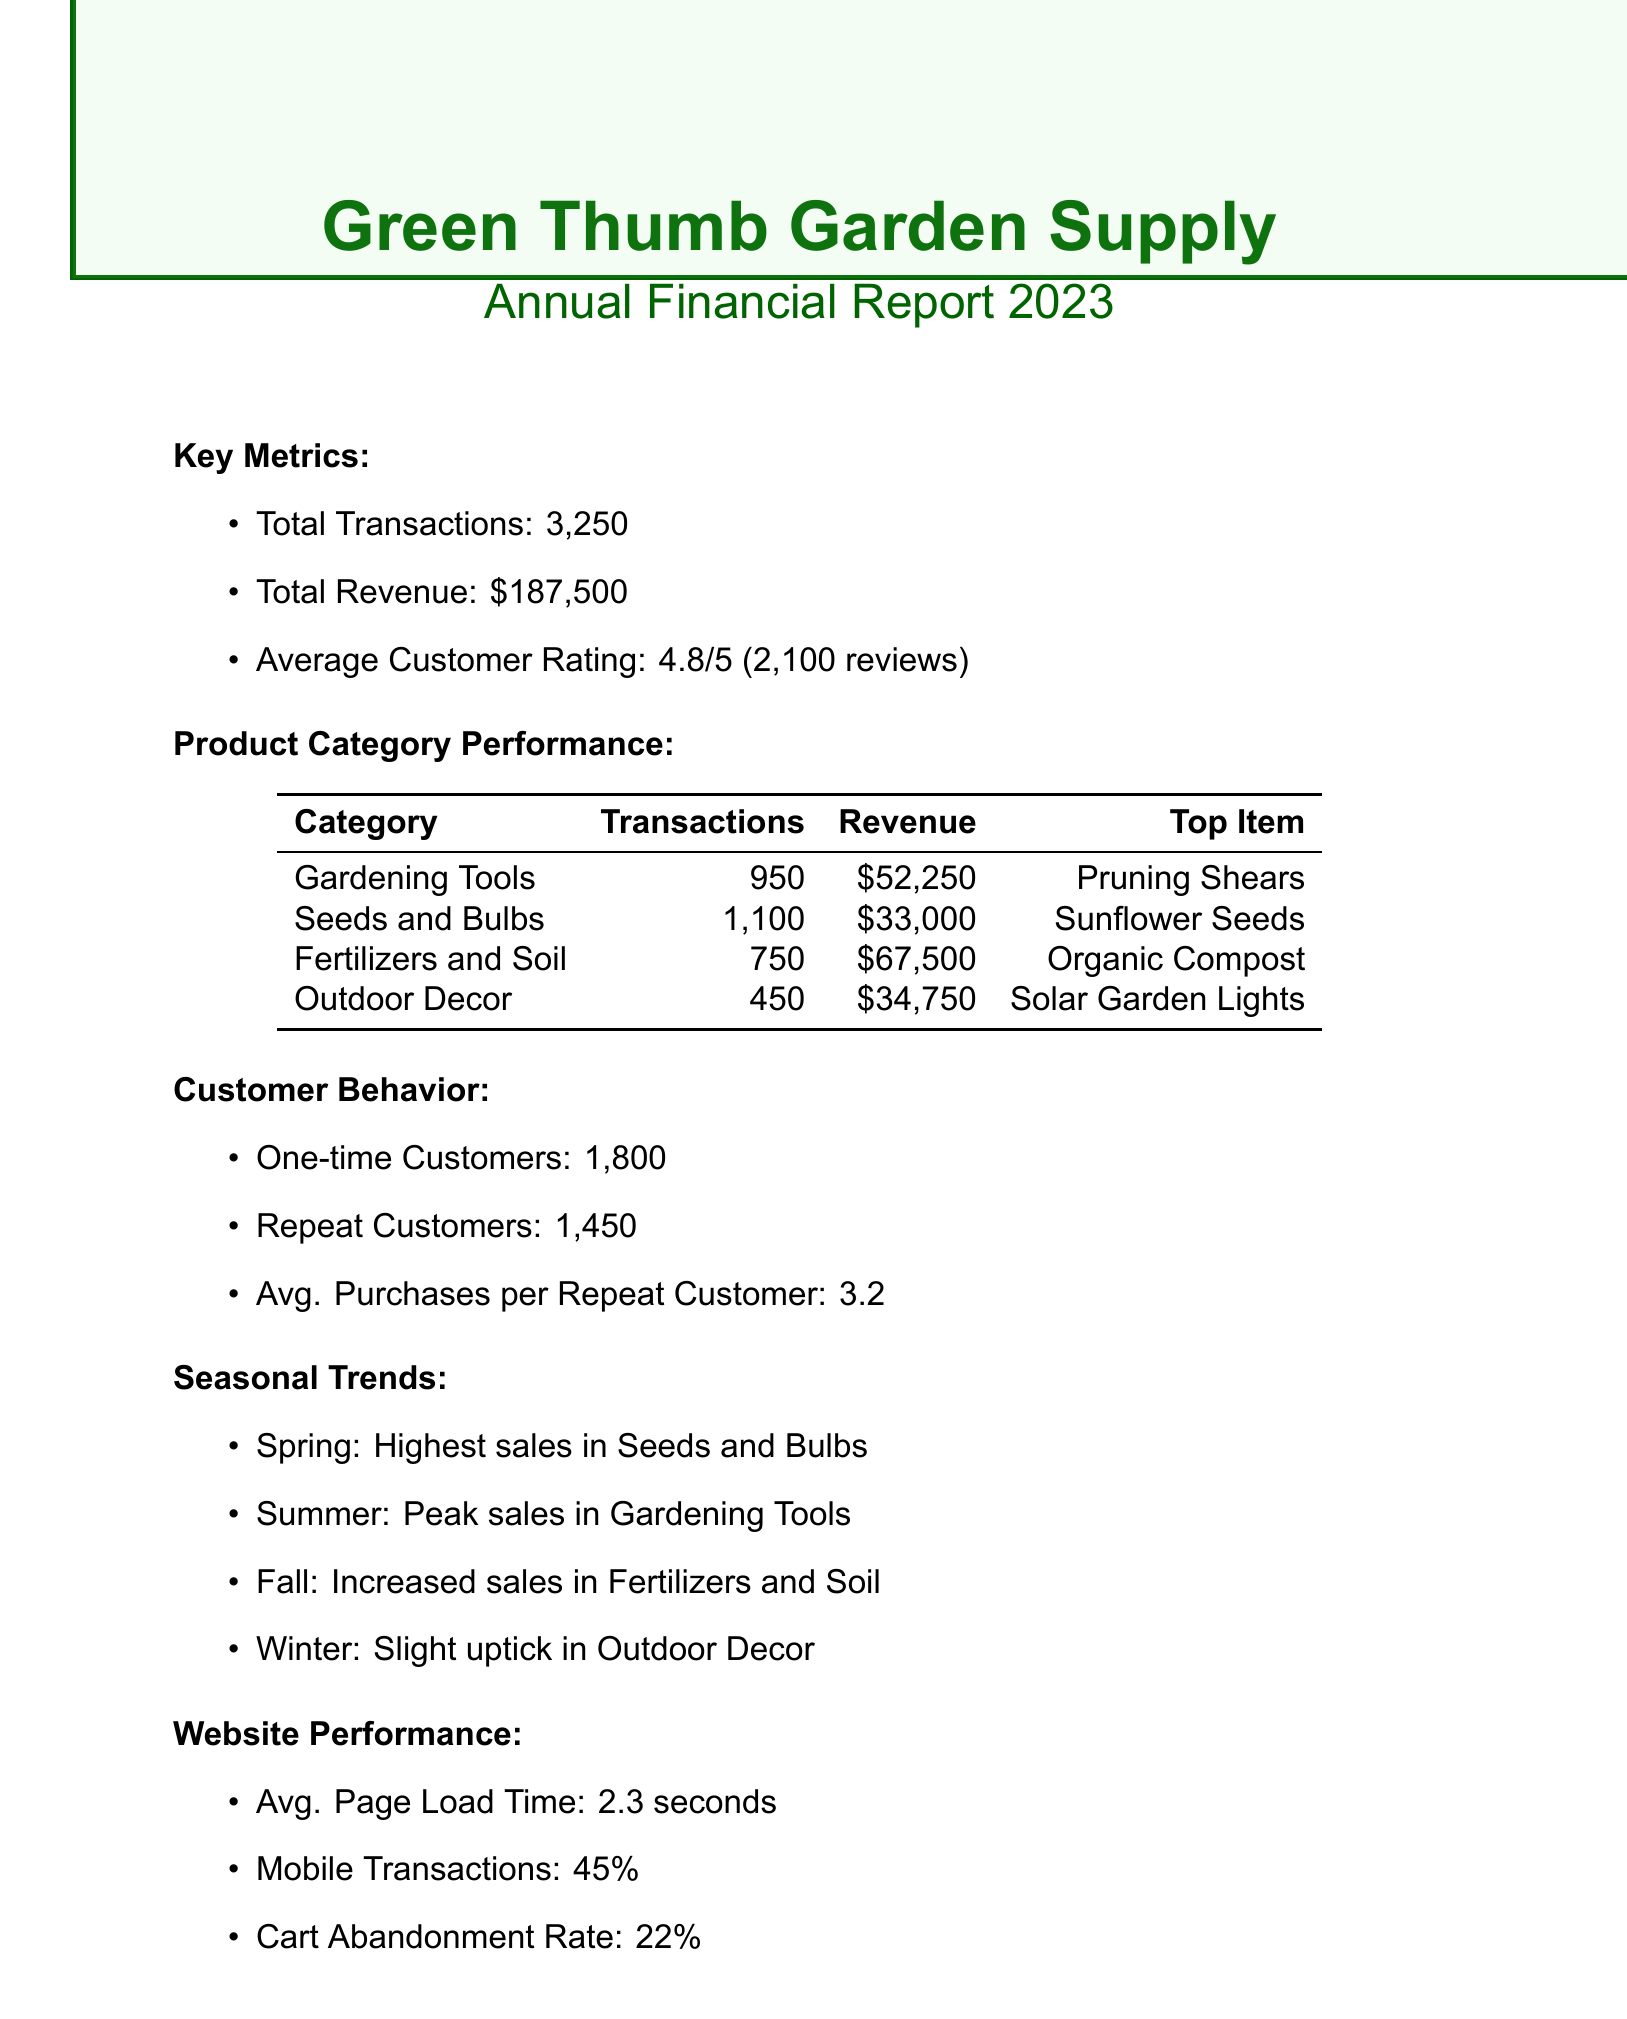What is the total number of transactions? The total number of transactions is stated directly in the document under key metrics.
Answer: 3250 What product category had the highest revenue? The product category with the highest revenue is determined from the revenue data provided in the product category performance section.
Answer: Fertilizers and Soil How many repeat customers were there? The number of repeat customers is indicated in the customer behavior section of the document.
Answer: 1450 What is the total revenue for Gardening Tools? The total revenue for Gardening Tools can be found in the product category performance section.
Answer: $52,250 What is the average customer rating? The average customer rating is mentioned in the key metrics of the document.
Answer: 4.8 Which season had the highest sales in Seeds and Bulbs? The season with the highest sales in Seeds and Bulbs is explicitly stated in the seasonal trends section.
Answer: Spring What is the average purchases per repeat customer? The average purchases per repeat customer is provided in the customer behavior section of the document.
Answer: 3.2 What percentage of transactions were made on mobile? The percentage of mobile transactions is noted in the website performance section.
Answer: 45% What is the cart abandonment rate? The cart abandonment rate is specified in the website performance section.
Answer: 22% 